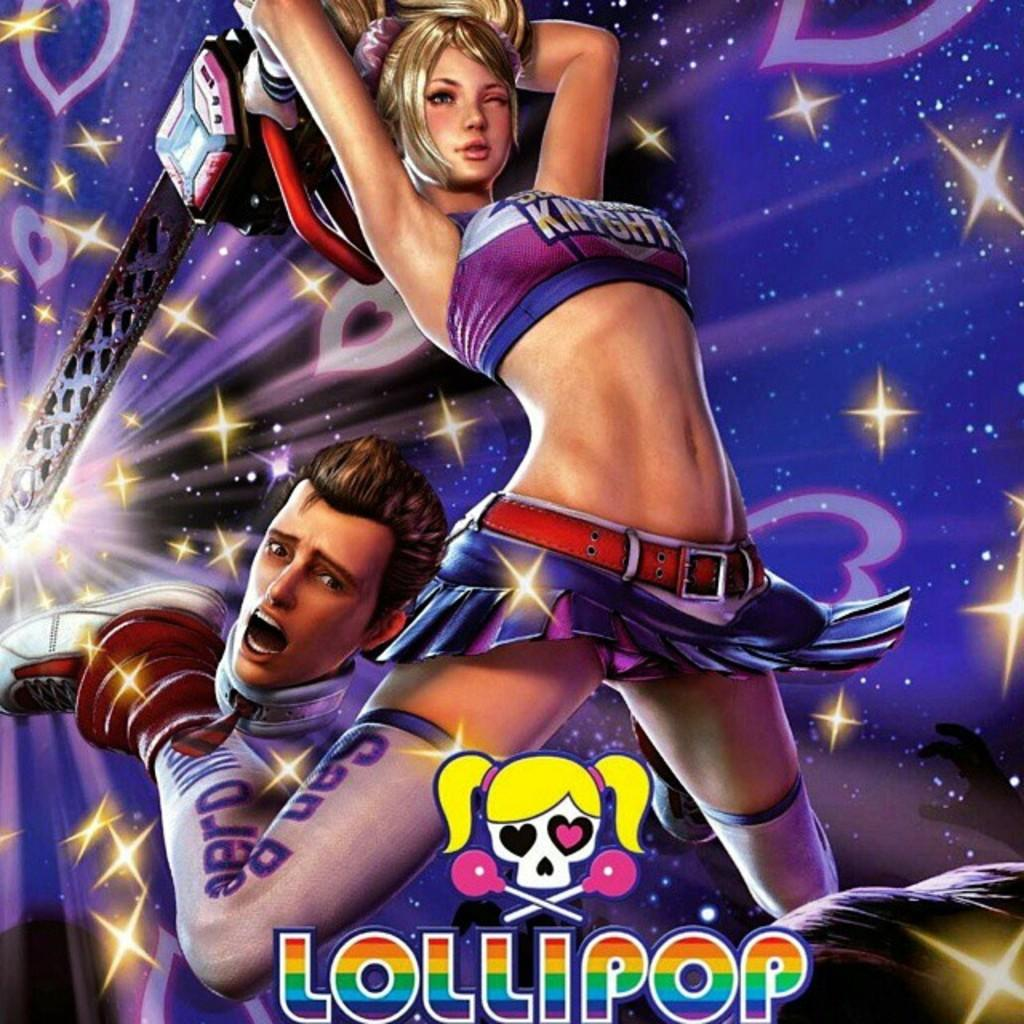<image>
Offer a succinct explanation of the picture presented. a lillipop ad with a cartoon girl on it 